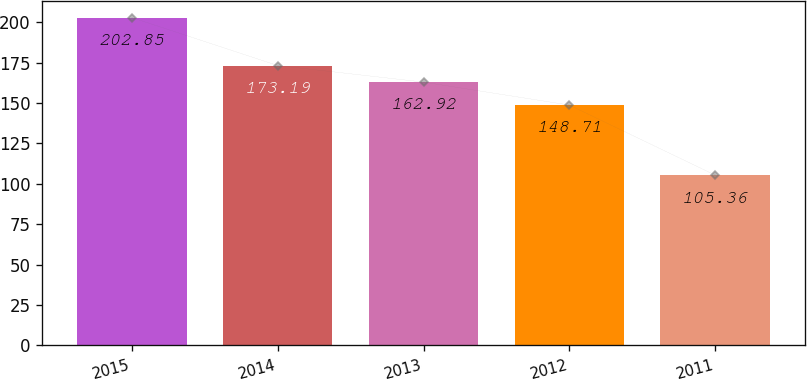<chart> <loc_0><loc_0><loc_500><loc_500><bar_chart><fcel>2015<fcel>2014<fcel>2013<fcel>2012<fcel>2011<nl><fcel>202.85<fcel>173.19<fcel>162.92<fcel>148.71<fcel>105.36<nl></chart> 